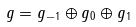Convert formula to latex. <formula><loc_0><loc_0><loc_500><loc_500>g = g _ { - 1 } \oplus g _ { 0 } \oplus g _ { 1 }</formula> 